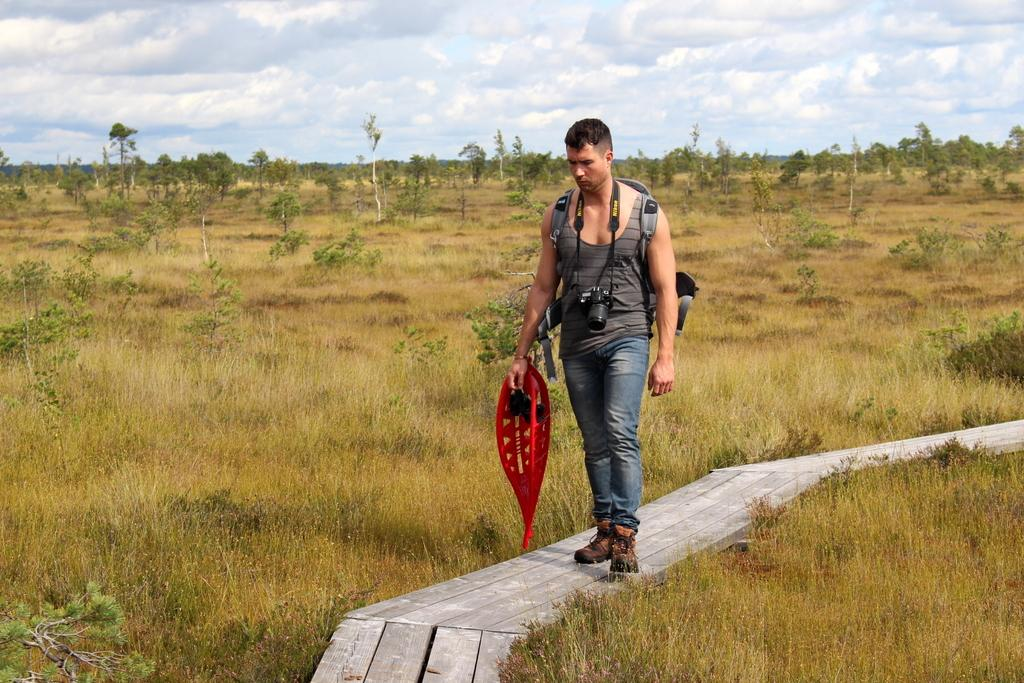What is the main subject of the image? There is a person in the image. What is the person holding in the image? The person is holding an object. What type of equipment is the person wearing? The person is wearing a backpack and a camera. What type of natural environment is visible in the image? There are plants, grass, and trees visible in the image. What is visible in the background of the image? The sky is visible in the background of the image, and clouds are present in the sky. What is the person's mindset while standing near the boundary of the leg in the image? There is no mention of a boundary or leg in the image. The image features a person holding an object, wearing a backpack and a camera, and standing amidst plants, grass, trees, and a sky with clouds. 